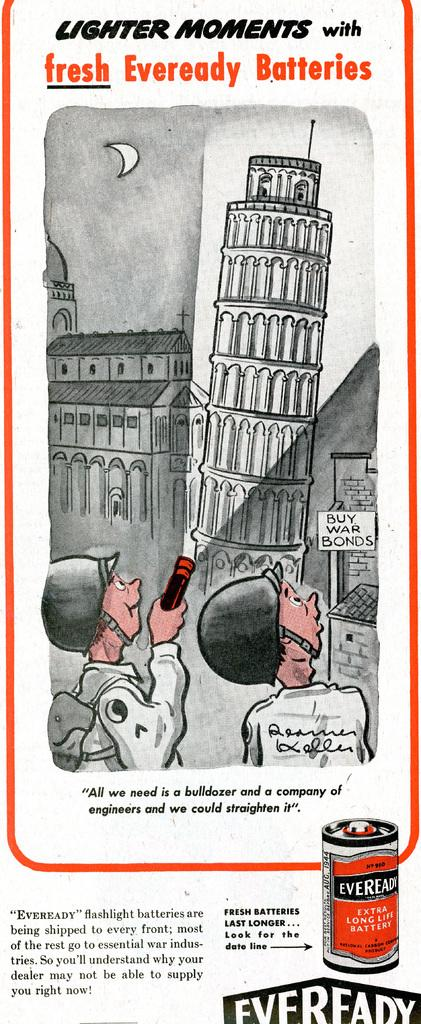What is depicted on the poster in the image? The poster contains text and images of buildings. What are the two people in the image doing? They are standing in front of the buildings. Can you describe the object one of the people is holding? One of the people is holding a torch light. What type of berry can be seen growing on the buildings in the image? There are no berries visible on the buildings in the image; the poster only shows images of buildings. What type of hall or office can be seen in the image? The image does not depict a hall or office; it only shows a poster with images of buildings and two people standing in front of them. 